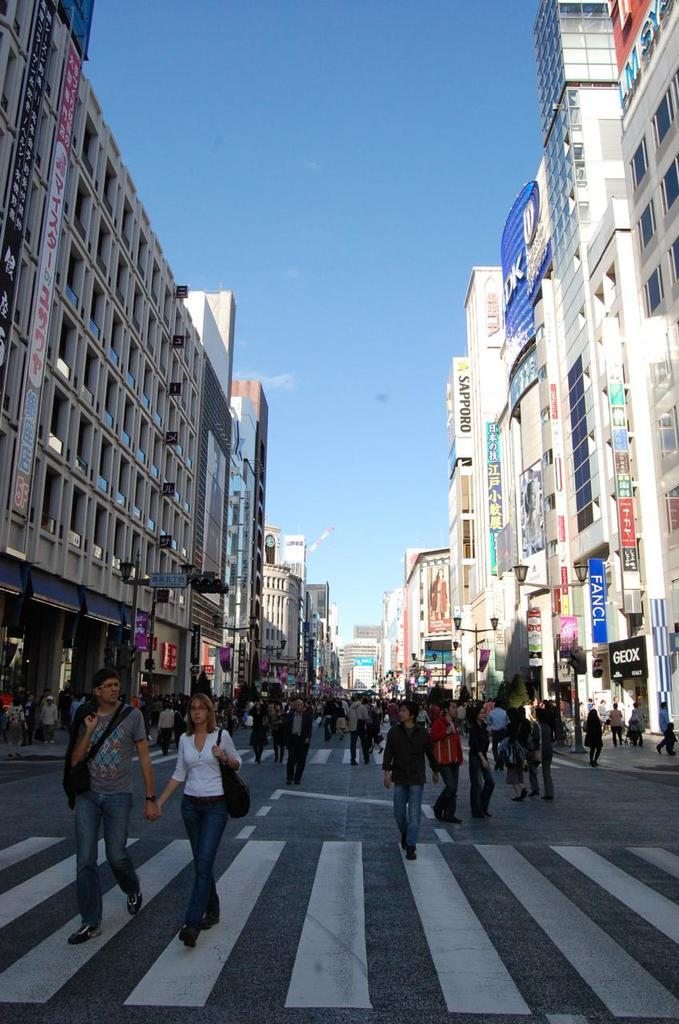How many people are in the image? There is a group of people in the image, but the exact number is not specified. What type of structures can be seen in the image? There are buildings in the image. What are the name boards used for in the image? Name boards are present in the image, but their purpose is not specified. What can be seen illuminating the scene? Lights are visible in the image. What is visible in the background of the image? The sky is visible in the background of the image. How many firemen are present in the image? There is no mention of firemen in the image. 